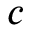<formula> <loc_0><loc_0><loc_500><loc_500>c</formula> 